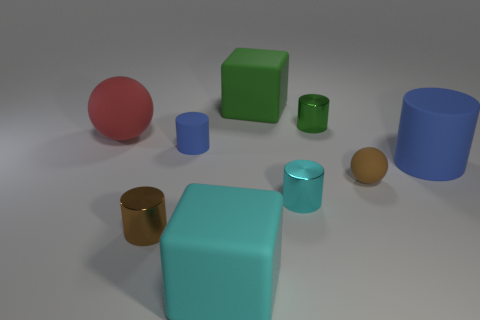Does the big cylinder have the same material as the small cyan thing?
Offer a terse response. No. There is a green cube that is the same size as the red object; what material is it?
Offer a terse response. Rubber. How many objects are blue matte objects that are to the left of the small cyan thing or small cyan things?
Keep it short and to the point. 2. Are there the same number of rubber objects in front of the small brown cylinder and large purple matte cylinders?
Your response must be concise. No. Does the small matte ball have the same color as the tiny matte cylinder?
Ensure brevity in your answer.  No. The tiny cylinder that is on the left side of the small cyan cylinder and in front of the brown matte ball is what color?
Your response must be concise. Brown. How many balls are either small cyan rubber things or large things?
Offer a very short reply. 1. Is the number of brown matte balls that are left of the brown shiny object less than the number of big matte things?
Offer a very short reply. Yes. There is a green object that is the same material as the tiny cyan thing; what shape is it?
Your answer should be compact. Cylinder. How many small rubber things are the same color as the big cylinder?
Make the answer very short. 1. 